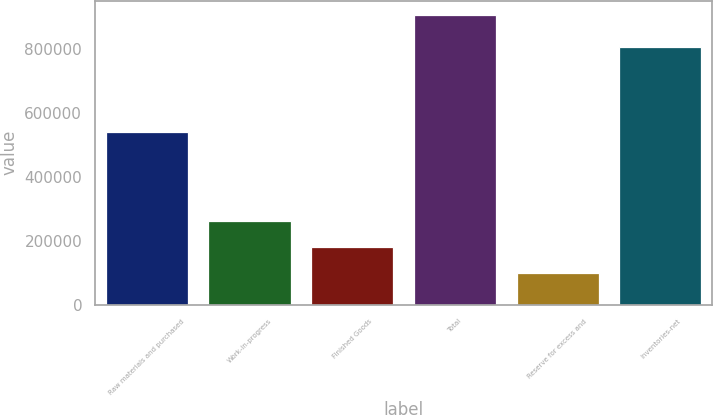Convert chart. <chart><loc_0><loc_0><loc_500><loc_500><bar_chart><fcel>Raw materials and purchased<fcel>Work-in-progress<fcel>Finished Goods<fcel>Total<fcel>Reserve for excess and<fcel>Inventories-net<nl><fcel>540290<fcel>260409<fcel>179880<fcel>904643<fcel>99351<fcel>805292<nl></chart> 